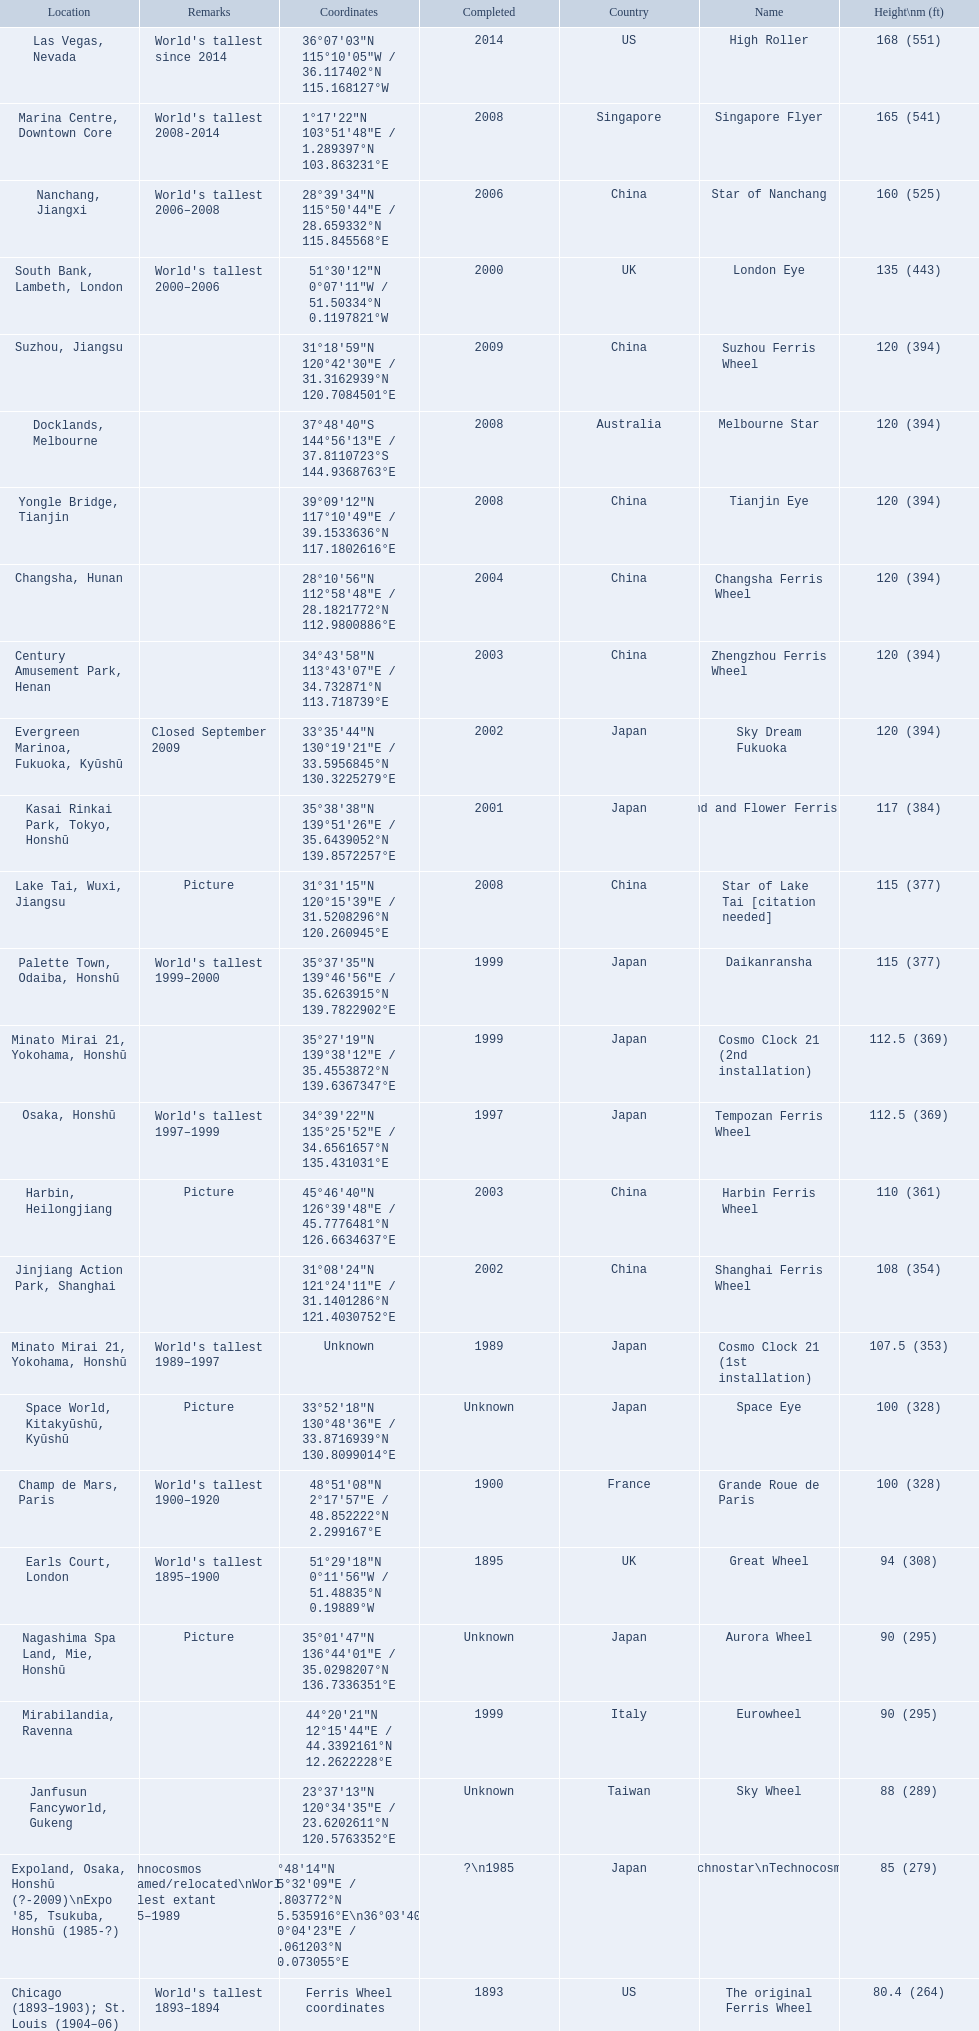What are all of the ferris wheels? High Roller, Singapore Flyer, Star of Nanchang, London Eye, Suzhou Ferris Wheel, Melbourne Star, Tianjin Eye, Changsha Ferris Wheel, Zhengzhou Ferris Wheel, Sky Dream Fukuoka, Diamond and Flower Ferris Wheel, Star of Lake Tai [citation needed], Daikanransha, Cosmo Clock 21 (2nd installation), Tempozan Ferris Wheel, Harbin Ferris Wheel, Shanghai Ferris Wheel, Cosmo Clock 21 (1st installation), Space Eye, Grande Roue de Paris, Great Wheel, Aurora Wheel, Eurowheel, Sky Wheel, Technostar\nTechnocosmos, The original Ferris Wheel. And when were they completed? 2014, 2008, 2006, 2000, 2009, 2008, 2008, 2004, 2003, 2002, 2001, 2008, 1999, 1999, 1997, 2003, 2002, 1989, Unknown, 1900, 1895, Unknown, 1999, Unknown, ?\n1985, 1893. And among star of lake tai, star of nanchang, and melbourne star, which ferris wheel is oldest? Star of Nanchang. 